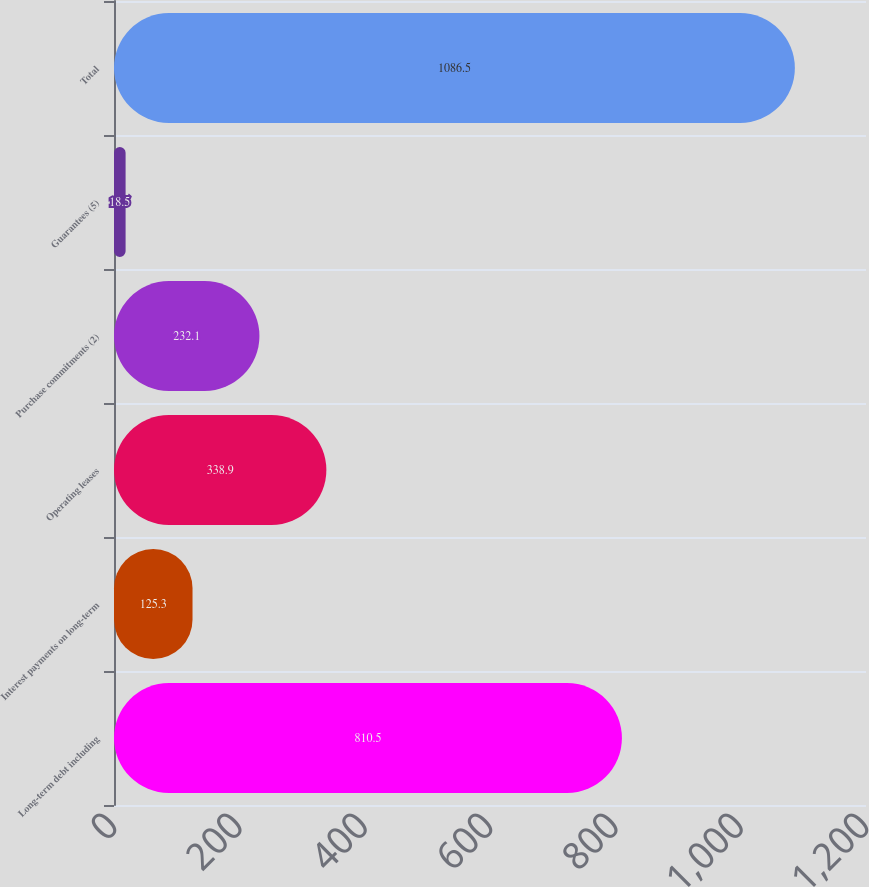Convert chart to OTSL. <chart><loc_0><loc_0><loc_500><loc_500><bar_chart><fcel>Long-term debt including<fcel>Interest payments on long-term<fcel>Operating leases<fcel>Purchase commitments (2)<fcel>Guarantees (5)<fcel>Total<nl><fcel>810.5<fcel>125.3<fcel>338.9<fcel>232.1<fcel>18.5<fcel>1086.5<nl></chart> 